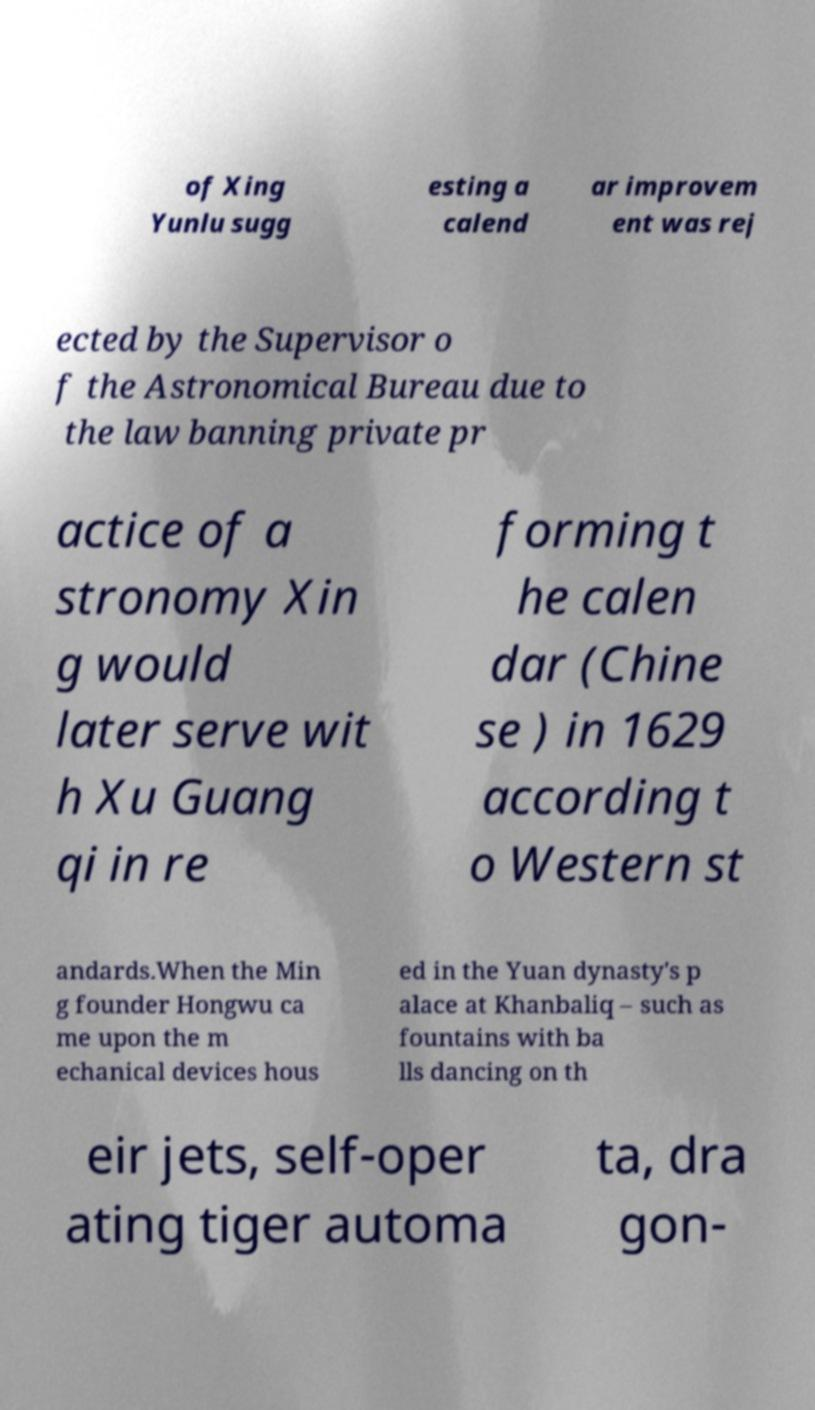I need the written content from this picture converted into text. Can you do that? of Xing Yunlu sugg esting a calend ar improvem ent was rej ected by the Supervisor o f the Astronomical Bureau due to the law banning private pr actice of a stronomy Xin g would later serve wit h Xu Guang qi in re forming t he calen dar (Chine se ) in 1629 according t o Western st andards.When the Min g founder Hongwu ca me upon the m echanical devices hous ed in the Yuan dynasty's p alace at Khanbaliq – such as fountains with ba lls dancing on th eir jets, self-oper ating tiger automa ta, dra gon- 